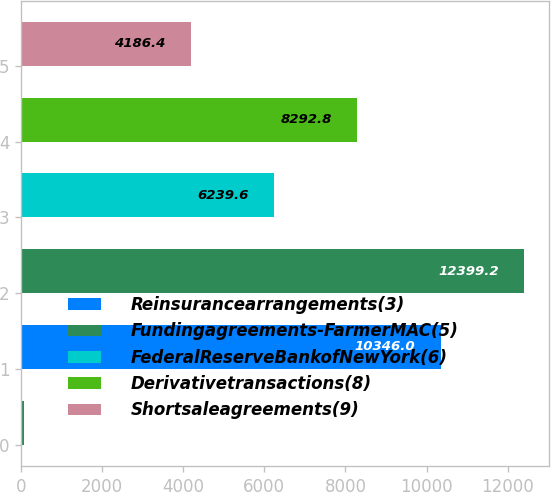Convert chart. <chart><loc_0><loc_0><loc_500><loc_500><bar_chart><ecel><fcel>Reinsurancearrangements(3)<fcel>Fundingagreements-FarmerMAC(5)<fcel>FederalReserveBankofNewYork(6)<fcel>Derivativetransactions(8)<fcel>Shortsaleagreements(9)<nl><fcel>80<fcel>10346<fcel>12399.2<fcel>6239.6<fcel>8292.8<fcel>4186.4<nl></chart> 